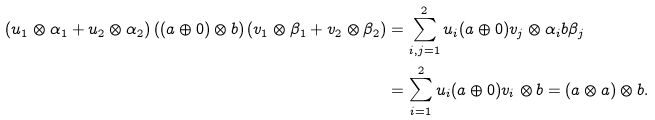Convert formula to latex. <formula><loc_0><loc_0><loc_500><loc_500>( u _ { 1 } \otimes \alpha _ { 1 } + u _ { 2 } \otimes \alpha _ { 2 } ) \left ( ( a \oplus 0 ) \otimes b \right ) ( v _ { 1 } \otimes \beta _ { 1 } + v _ { 2 } \otimes \beta _ { 2 } ) & = \sum _ { i , j = 1 } ^ { 2 } u _ { i } ( a \oplus 0 ) v _ { j } \otimes \alpha _ { i } b \beta _ { j } \\ & = \sum _ { i = 1 } ^ { 2 } u _ { i } ( a \oplus 0 ) v _ { i } \otimes b = ( a \otimes a ) \otimes b .</formula> 